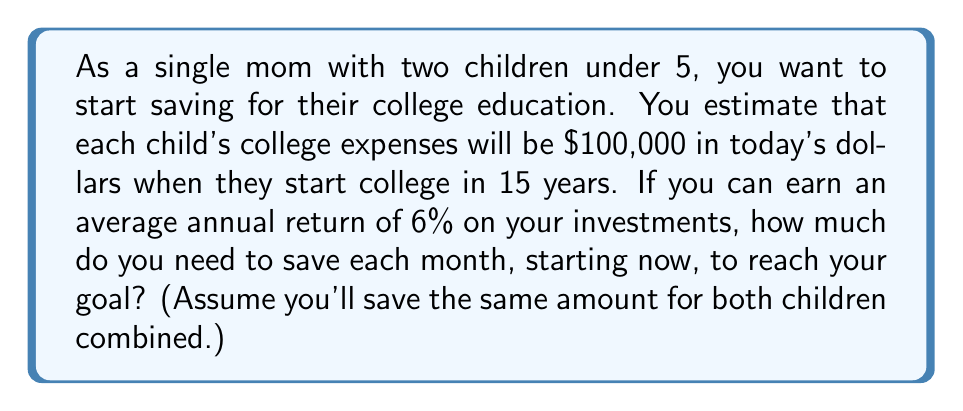Show me your answer to this math problem. Let's approach this step-by-step:

1) First, we need to calculate the future value of $200,000 (for both children) in 15 years, assuming 6% inflation:

   $FV = 200000 * (1 + 0.06)^{15} = 200000 * 2.3966 = $479,320$

2) Now, we need to find the monthly payment (PMT) that will grow to $479,320 in 15 years at 6% interest, compounded monthly.

3) We'll use the future value of an annuity formula:

   $FV = PMT * \frac{(1 + r/n)^{nt} - 1}{r/n}$

   Where:
   FV = Future Value ($479,320)
   PMT = Monthly Payment (what we're solving for)
   r = Annual Interest Rate (6% = 0.06)
   n = Number of compounds per year (12 for monthly)
   t = Number of years (15)

4) Plugging in the values:

   $479320 = PMT * \frac{(1 + 0.06/12)^{12*15} - 1}{0.06/12}$

5) Simplifying:

   $479320 = PMT * 260.0366$

6) Solving for PMT:

   $PMT = 479320 / 260.0366 = 1843.29$
Answer: You need to save approximately $1,843 per month to reach your goal. 